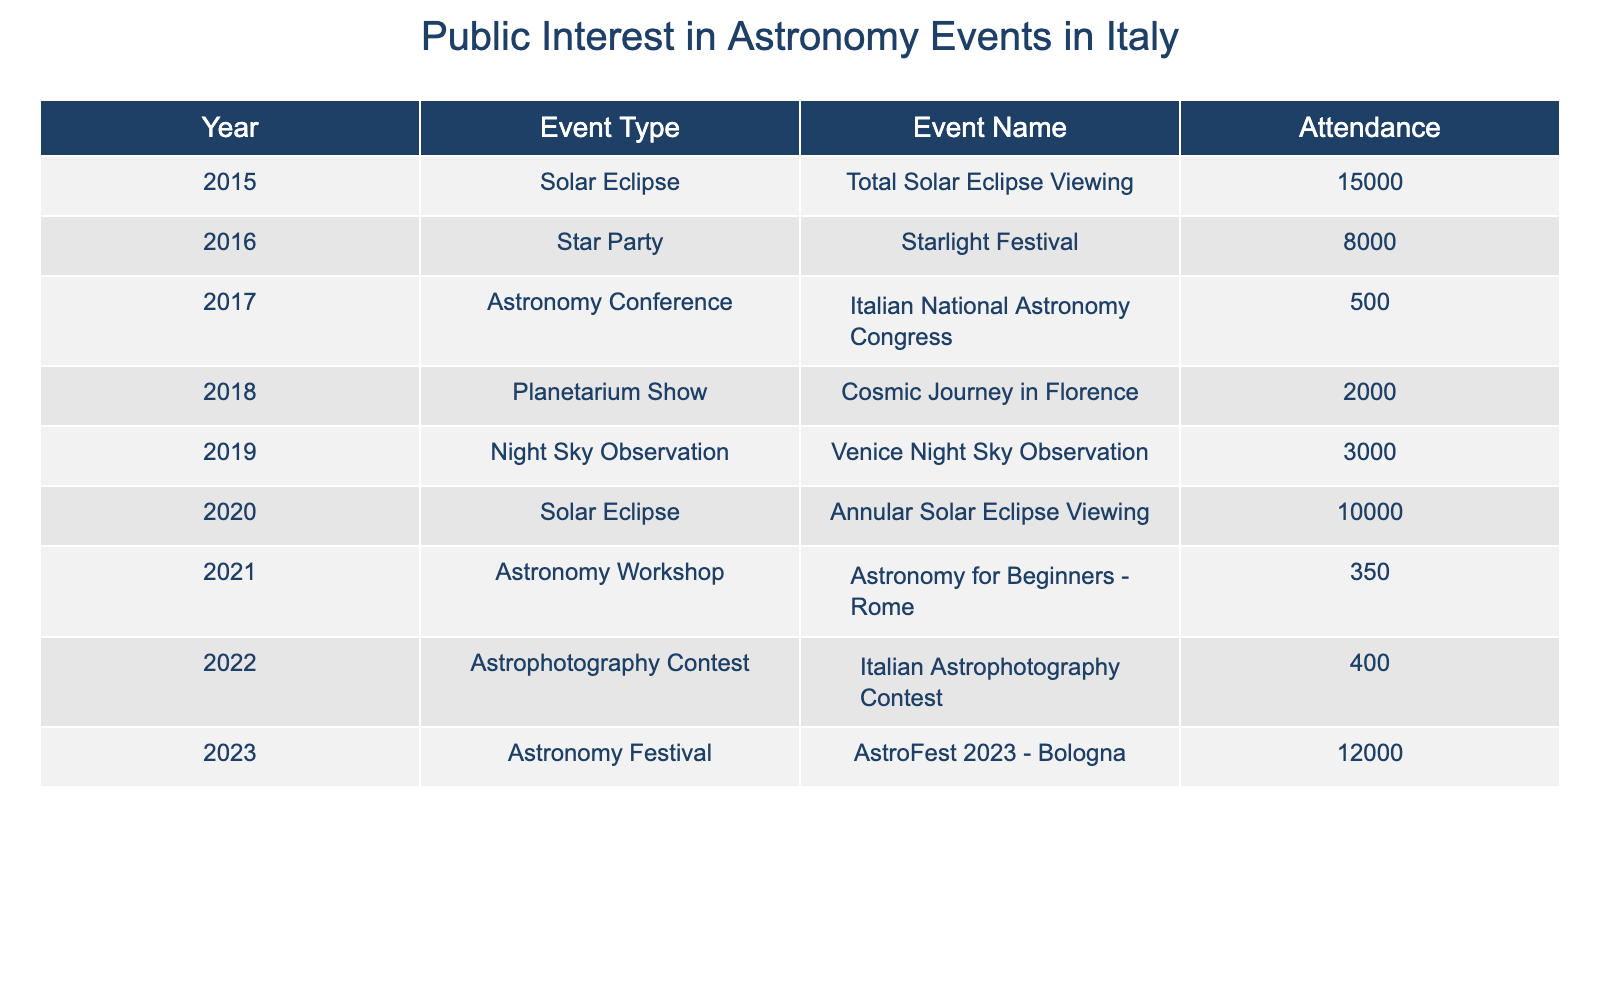What was the highest attendance at an astronomy event in Italy from 2015 to 2023? The table shows that the highest attendance was for the Total Solar Eclipse Viewing event in 2015, with 15,000 attendees.
Answer: 15000 What type of event had the lowest attendance in 2022? The Astronomy Workshop in 2021 had the lowest attendance, with only 350 participants.
Answer: 350 In which year did the Solar Eclipse event take place besides 2015, and what was its attendance? Looking at the table, the Annular Solar Eclipse Viewing event occurred in 2020 with 10,000 attendees.
Answer: 10000 What is the average attendance for all events listed in the table? To find the average, sum all attendance numbers: (15000 + 8000 + 500 + 2000 + 3000 + 10000 + 350 + 400 + 12000) = 39,250. There are 9 events, so the average is 39250 / 9 = 4361.11, which rounds to approximately 4361.
Answer: 4361 Did the attendance for astronomy events increase from 2021 to 2023? Yes, attendance in 2021 was 350, and in 2023 it was 12,000, indicating a significant increase.
Answer: Yes What is the total attendance of solar eclipse events from the data? The total attendance for solar eclipse events includes 15,000 in 2015 and 10,000 in 2020, adding up to 25,000 attendees.
Answer: 25000 How many types of astronomy events were recorded in the years listed in the table? There are six unique event types in the table: Solar Eclipse, Star Party, Astronomy Conference, Planetarium Show, Night Sky Observation, and Astronomy Workshop, totaling six.
Answer: 6 Which year had the highest attendance at an Astronomy Conference? The table shows that in 2017, the attendance for the Astronomy Conference (Italian National Astronomy Congress) was only 500, which was the only entry for that event type, making it the highest.
Answer: 500 Was the attendance for the Astrophotography Contest higher or lower than the Planetarium Show? The Astrophotography Contest in 2022 had 400 attendees while the Planetarium Show in 2018 had 2,000 attendees, so it was lower.
Answer: Lower 